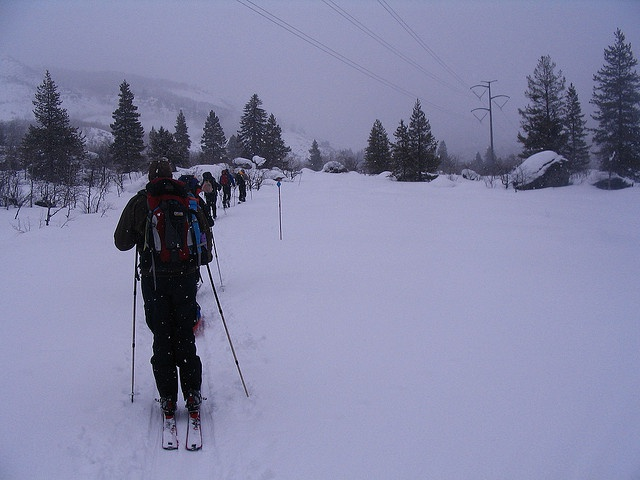Describe the objects in this image and their specific colors. I can see people in gray, black, navy, and darkgray tones, backpack in gray, black, navy, and darkblue tones, skis in gray, purple, and black tones, people in gray, black, and darkgray tones, and people in gray, black, maroon, and navy tones in this image. 